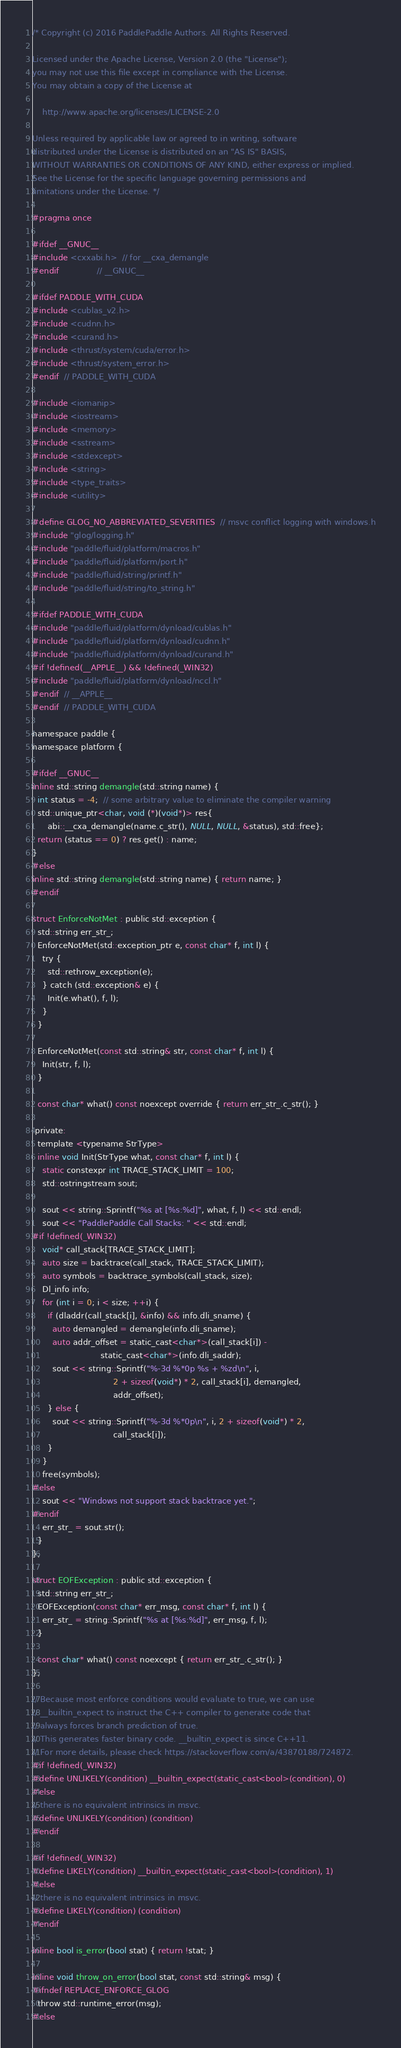Convert code to text. <code><loc_0><loc_0><loc_500><loc_500><_C_>/* Copyright (c) 2016 PaddlePaddle Authors. All Rights Reserved.

Licensed under the Apache License, Version 2.0 (the "License");
you may not use this file except in compliance with the License.
You may obtain a copy of the License at

    http://www.apache.org/licenses/LICENSE-2.0

Unless required by applicable law or agreed to in writing, software
distributed under the License is distributed on an "AS IS" BASIS,
WITHOUT WARRANTIES OR CONDITIONS OF ANY KIND, either express or implied.
See the License for the specific language governing permissions and
limitations under the License. */

#pragma once

#ifdef __GNUC__
#include <cxxabi.h>  // for __cxa_demangle
#endif               // __GNUC__

#ifdef PADDLE_WITH_CUDA
#include <cublas_v2.h>
#include <cudnn.h>
#include <curand.h>
#include <thrust/system/cuda/error.h>
#include <thrust/system_error.h>
#endif  // PADDLE_WITH_CUDA

#include <iomanip>
#include <iostream>
#include <memory>
#include <sstream>
#include <stdexcept>
#include <string>
#include <type_traits>
#include <utility>

#define GLOG_NO_ABBREVIATED_SEVERITIES  // msvc conflict logging with windows.h
#include "glog/logging.h"
#include "paddle/fluid/platform/macros.h"
#include "paddle/fluid/platform/port.h"
#include "paddle/fluid/string/printf.h"
#include "paddle/fluid/string/to_string.h"

#ifdef PADDLE_WITH_CUDA
#include "paddle/fluid/platform/dynload/cublas.h"
#include "paddle/fluid/platform/dynload/cudnn.h"
#include "paddle/fluid/platform/dynload/curand.h"
#if !defined(__APPLE__) && !defined(_WIN32)
#include "paddle/fluid/platform/dynload/nccl.h"
#endif  // __APPLE__
#endif  // PADDLE_WITH_CUDA

namespace paddle {
namespace platform {

#ifdef __GNUC__
inline std::string demangle(std::string name) {
  int status = -4;  // some arbitrary value to eliminate the compiler warning
  std::unique_ptr<char, void (*)(void*)> res{
      abi::__cxa_demangle(name.c_str(), NULL, NULL, &status), std::free};
  return (status == 0) ? res.get() : name;
}
#else
inline std::string demangle(std::string name) { return name; }
#endif

struct EnforceNotMet : public std::exception {
  std::string err_str_;
  EnforceNotMet(std::exception_ptr e, const char* f, int l) {
    try {
      std::rethrow_exception(e);
    } catch (std::exception& e) {
      Init(e.what(), f, l);
    }
  }

  EnforceNotMet(const std::string& str, const char* f, int l) {
    Init(str, f, l);
  }

  const char* what() const noexcept override { return err_str_.c_str(); }

 private:
  template <typename StrType>
  inline void Init(StrType what, const char* f, int l) {
    static constexpr int TRACE_STACK_LIMIT = 100;
    std::ostringstream sout;

    sout << string::Sprintf("%s at [%s:%d]", what, f, l) << std::endl;
    sout << "PaddlePaddle Call Stacks: " << std::endl;
#if !defined(_WIN32)
    void* call_stack[TRACE_STACK_LIMIT];
    auto size = backtrace(call_stack, TRACE_STACK_LIMIT);
    auto symbols = backtrace_symbols(call_stack, size);
    Dl_info info;
    for (int i = 0; i < size; ++i) {
      if (dladdr(call_stack[i], &info) && info.dli_sname) {
        auto demangled = demangle(info.dli_sname);
        auto addr_offset = static_cast<char*>(call_stack[i]) -
                           static_cast<char*>(info.dli_saddr);
        sout << string::Sprintf("%-3d %*0p %s + %zd\n", i,
                                2 + sizeof(void*) * 2, call_stack[i], demangled,
                                addr_offset);
      } else {
        sout << string::Sprintf("%-3d %*0p\n", i, 2 + sizeof(void*) * 2,
                                call_stack[i]);
      }
    }
    free(symbols);
#else
    sout << "Windows not support stack backtrace yet.";
#endif
    err_str_ = sout.str();
  }
};

struct EOFException : public std::exception {
  std::string err_str_;
  EOFException(const char* err_msg, const char* f, int l) {
    err_str_ = string::Sprintf("%s at [%s:%d]", err_msg, f, l);
  }

  const char* what() const noexcept { return err_str_.c_str(); }
};

// Because most enforce conditions would evaluate to true, we can use
// __builtin_expect to instruct the C++ compiler to generate code that
// always forces branch prediction of true.
// This generates faster binary code. __builtin_expect is since C++11.
// For more details, please check https://stackoverflow.com/a/43870188/724872.
#if !defined(_WIN32)
#define UNLIKELY(condition) __builtin_expect(static_cast<bool>(condition), 0)
#else
// there is no equivalent intrinsics in msvc.
#define UNLIKELY(condition) (condition)
#endif

#if !defined(_WIN32)
#define LIKELY(condition) __builtin_expect(static_cast<bool>(condition), 1)
#else
// there is no equivalent intrinsics in msvc.
#define LIKELY(condition) (condition)
#endif

inline bool is_error(bool stat) { return !stat; }

inline void throw_on_error(bool stat, const std::string& msg) {
#ifndef REPLACE_ENFORCE_GLOG
  throw std::runtime_error(msg);
#else</code> 